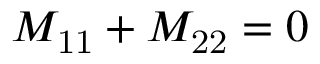<formula> <loc_0><loc_0><loc_500><loc_500>M _ { 1 1 } + M _ { 2 2 } = 0</formula> 